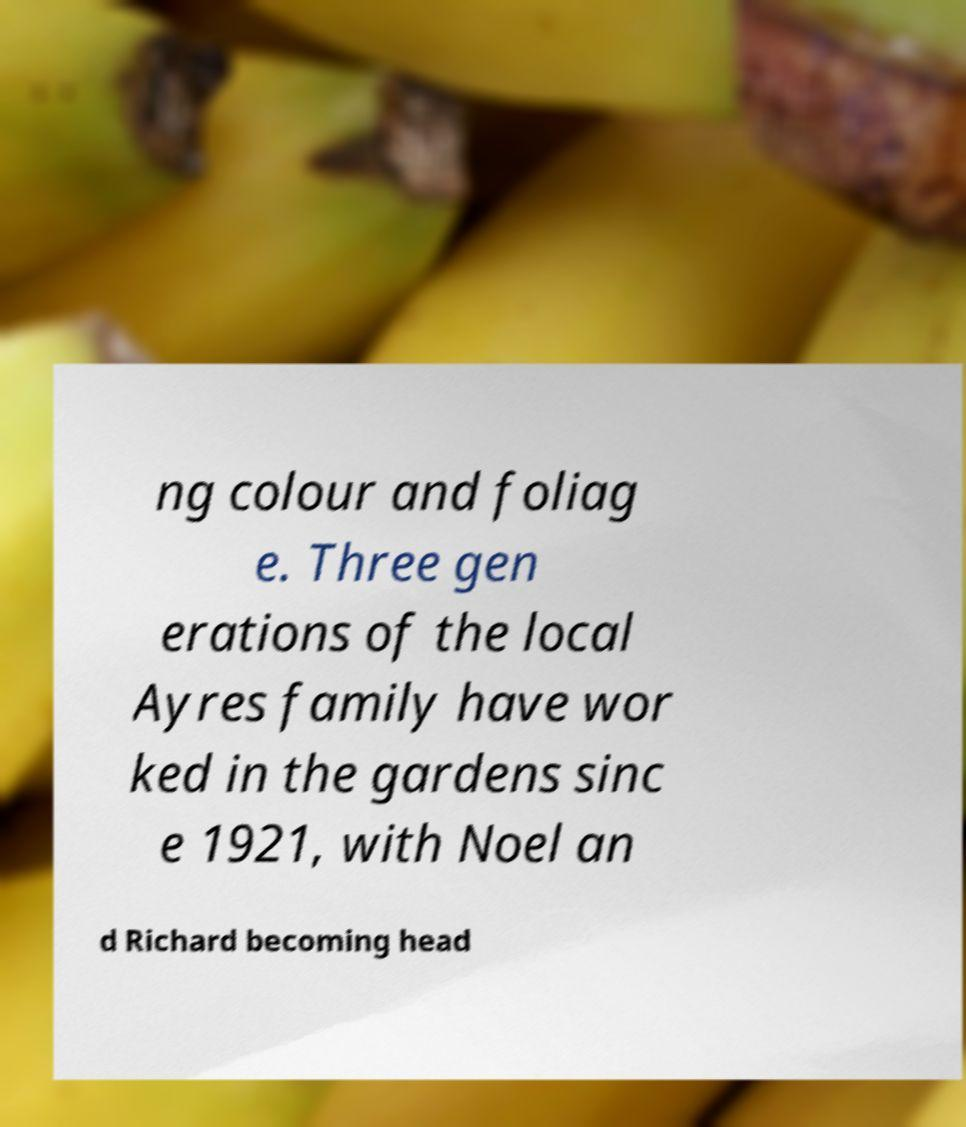There's text embedded in this image that I need extracted. Can you transcribe it verbatim? ng colour and foliag e. Three gen erations of the local Ayres family have wor ked in the gardens sinc e 1921, with Noel an d Richard becoming head 